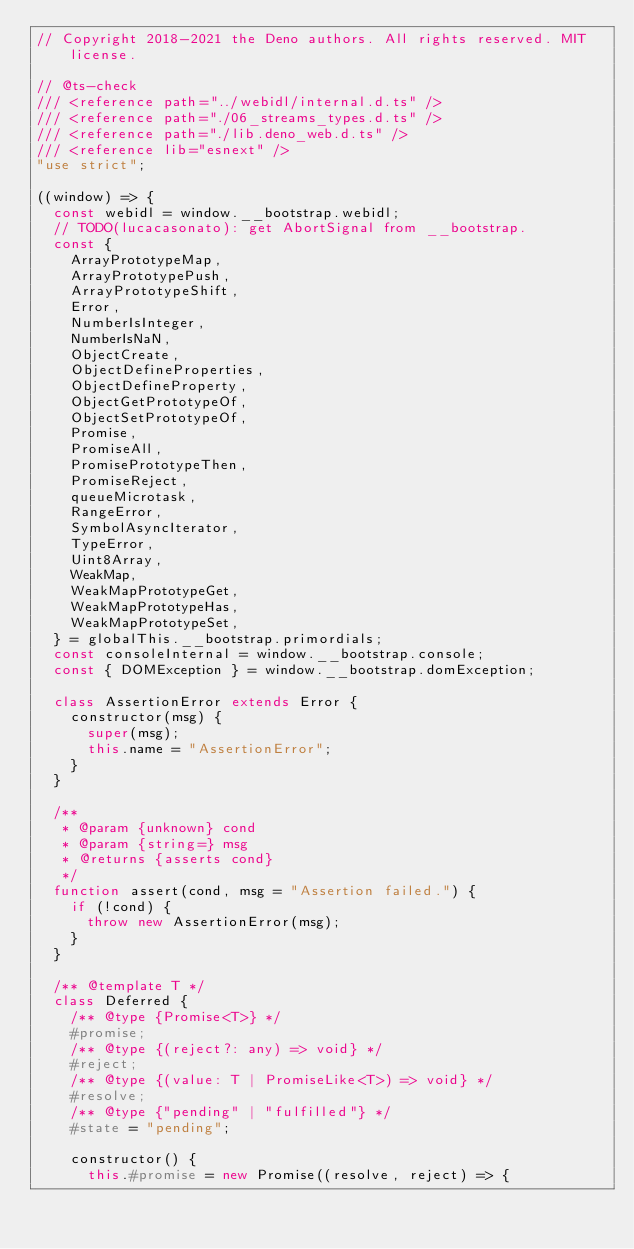<code> <loc_0><loc_0><loc_500><loc_500><_JavaScript_>// Copyright 2018-2021 the Deno authors. All rights reserved. MIT license.

// @ts-check
/// <reference path="../webidl/internal.d.ts" />
/// <reference path="./06_streams_types.d.ts" />
/// <reference path="./lib.deno_web.d.ts" />
/// <reference lib="esnext" />
"use strict";

((window) => {
  const webidl = window.__bootstrap.webidl;
  // TODO(lucacasonato): get AbortSignal from __bootstrap.
  const {
    ArrayPrototypeMap,
    ArrayPrototypePush,
    ArrayPrototypeShift,
    Error,
    NumberIsInteger,
    NumberIsNaN,
    ObjectCreate,
    ObjectDefineProperties,
    ObjectDefineProperty,
    ObjectGetPrototypeOf,
    ObjectSetPrototypeOf,
    Promise,
    PromiseAll,
    PromisePrototypeThen,
    PromiseReject,
    queueMicrotask,
    RangeError,
    SymbolAsyncIterator,
    TypeError,
    Uint8Array,
    WeakMap,
    WeakMapPrototypeGet,
    WeakMapPrototypeHas,
    WeakMapPrototypeSet,
  } = globalThis.__bootstrap.primordials;
  const consoleInternal = window.__bootstrap.console;
  const { DOMException } = window.__bootstrap.domException;

  class AssertionError extends Error {
    constructor(msg) {
      super(msg);
      this.name = "AssertionError";
    }
  }

  /**
   * @param {unknown} cond
   * @param {string=} msg
   * @returns {asserts cond}
   */
  function assert(cond, msg = "Assertion failed.") {
    if (!cond) {
      throw new AssertionError(msg);
    }
  }

  /** @template T */
  class Deferred {
    /** @type {Promise<T>} */
    #promise;
    /** @type {(reject?: any) => void} */
    #reject;
    /** @type {(value: T | PromiseLike<T>) => void} */
    #resolve;
    /** @type {"pending" | "fulfilled"} */
    #state = "pending";

    constructor() {
      this.#promise = new Promise((resolve, reject) => {</code> 